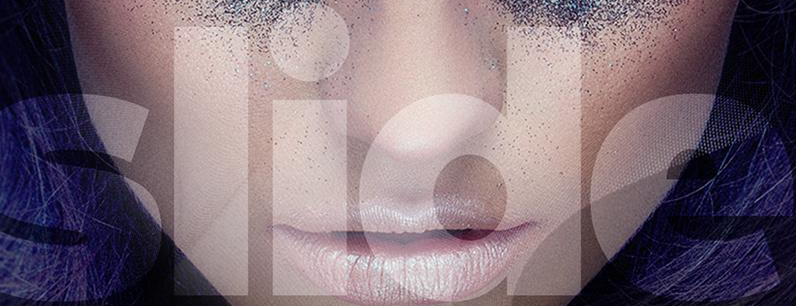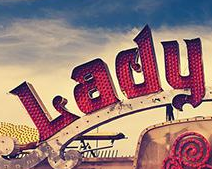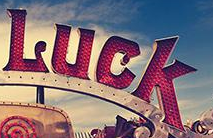What words can you see in these images in sequence, separated by a semicolon? slide; Lady; Luck 